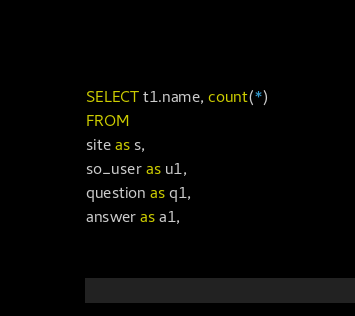<code> <loc_0><loc_0><loc_500><loc_500><_SQL_>SELECT t1.name, count(*)
FROM
site as s,
so_user as u1,
question as q1,
answer as a1,</code> 